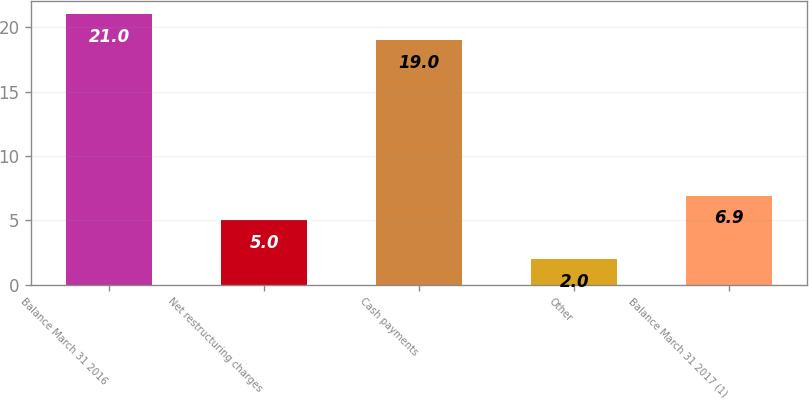Convert chart. <chart><loc_0><loc_0><loc_500><loc_500><bar_chart><fcel>Balance March 31 2016<fcel>Net restructuring charges<fcel>Cash payments<fcel>Other<fcel>Balance March 31 2017 (1)<nl><fcel>21<fcel>5<fcel>19<fcel>2<fcel>6.9<nl></chart> 